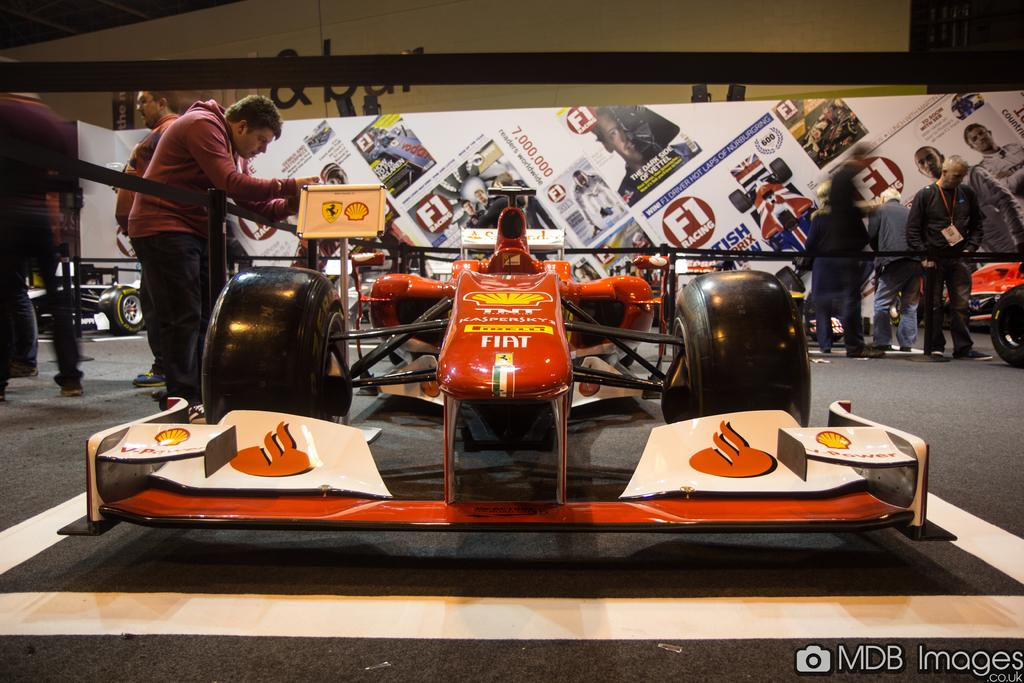What type of vehicles are in the image? There are racing cars in the image. What else can be seen in the background of the image? There are people in the background of the image. What objects are visible in the image besides the racing cars? There are boards visible in the image. What surface can be seen at the bottom of the image? There is a road at the bottom of the image. What type of fowl can be seen flying over the racing cars in the image? There are no fowl visible in the image; it only features racing cars, people, boards, and a road. 